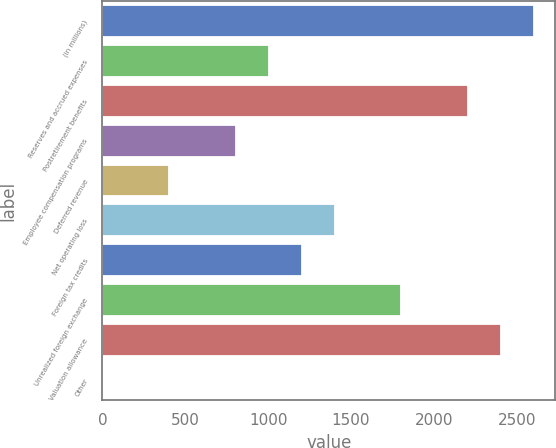Convert chart. <chart><loc_0><loc_0><loc_500><loc_500><bar_chart><fcel>(in millions)<fcel>Reserves and accrued expenses<fcel>Postretirement benefits<fcel>Employee compensation programs<fcel>Deferred revenue<fcel>Net operating loss<fcel>Foreign tax credits<fcel>Unrealized foreign exchange<fcel>Valuation allowance<fcel>Other<nl><fcel>2602.82<fcel>1003.3<fcel>2202.94<fcel>803.36<fcel>403.48<fcel>1403.18<fcel>1203.24<fcel>1803.06<fcel>2402.88<fcel>3.6<nl></chart> 